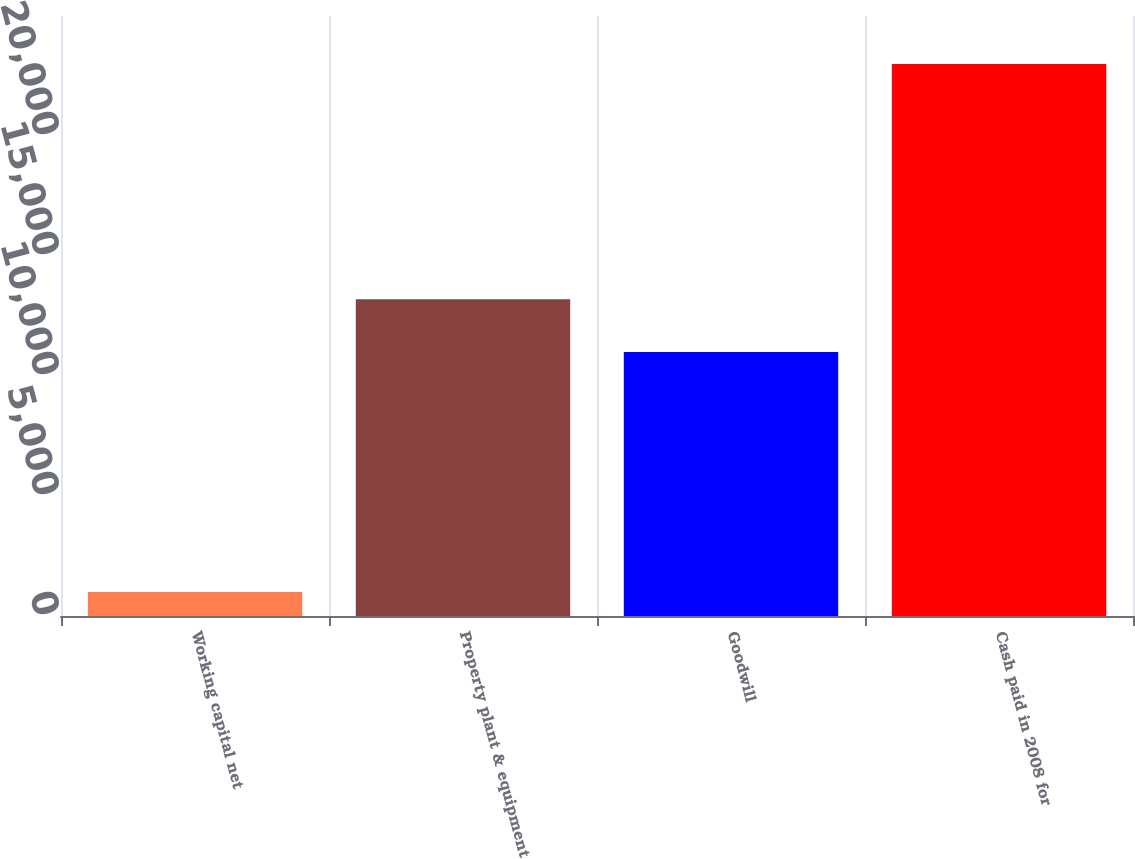<chart> <loc_0><loc_0><loc_500><loc_500><bar_chart><fcel>Working capital net<fcel>Property plant & equipment<fcel>Goodwill<fcel>Cash paid in 2008 for<nl><fcel>1000<fcel>13200<fcel>11000<fcel>23000<nl></chart> 